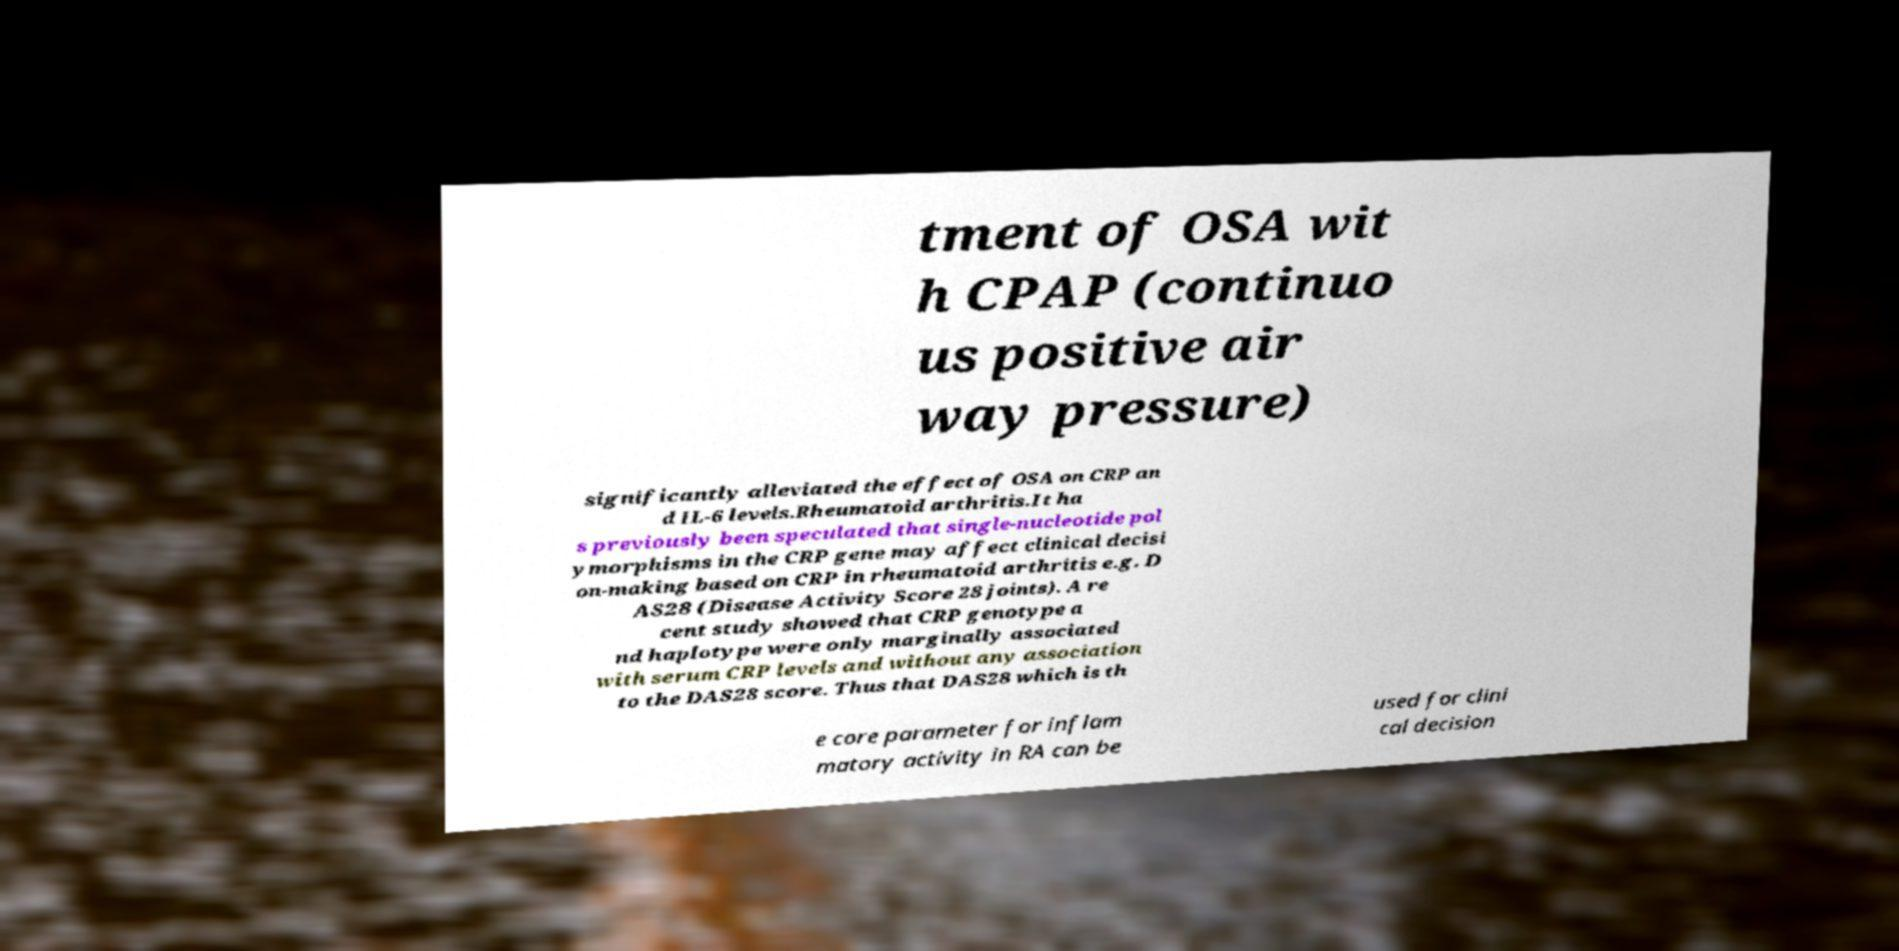Can you accurately transcribe the text from the provided image for me? tment of OSA wit h CPAP (continuo us positive air way pressure) significantly alleviated the effect of OSA on CRP an d IL-6 levels.Rheumatoid arthritis.It ha s previously been speculated that single-nucleotide pol ymorphisms in the CRP gene may affect clinical decisi on-making based on CRP in rheumatoid arthritis e.g. D AS28 (Disease Activity Score 28 joints). A re cent study showed that CRP genotype a nd haplotype were only marginally associated with serum CRP levels and without any association to the DAS28 score. Thus that DAS28 which is th e core parameter for inflam matory activity in RA can be used for clini cal decision 